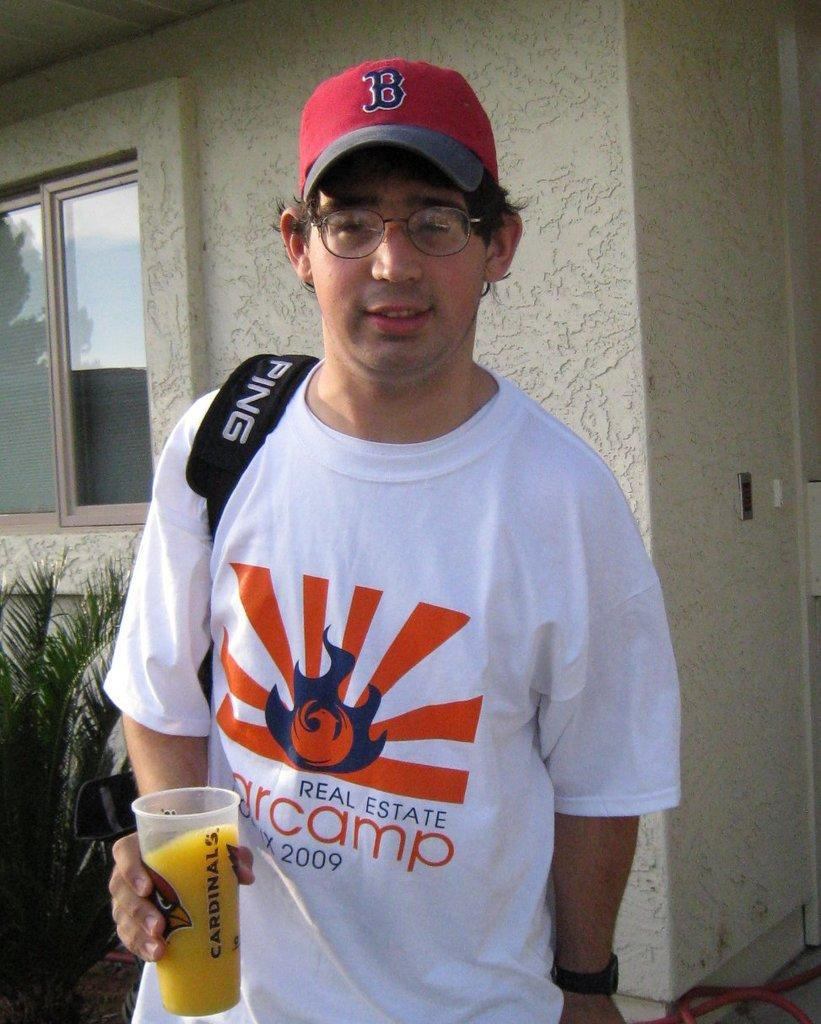<image>
Offer a succinct explanation of the picture presented. A cardinals fan  with a ping backpack on standing outside. 